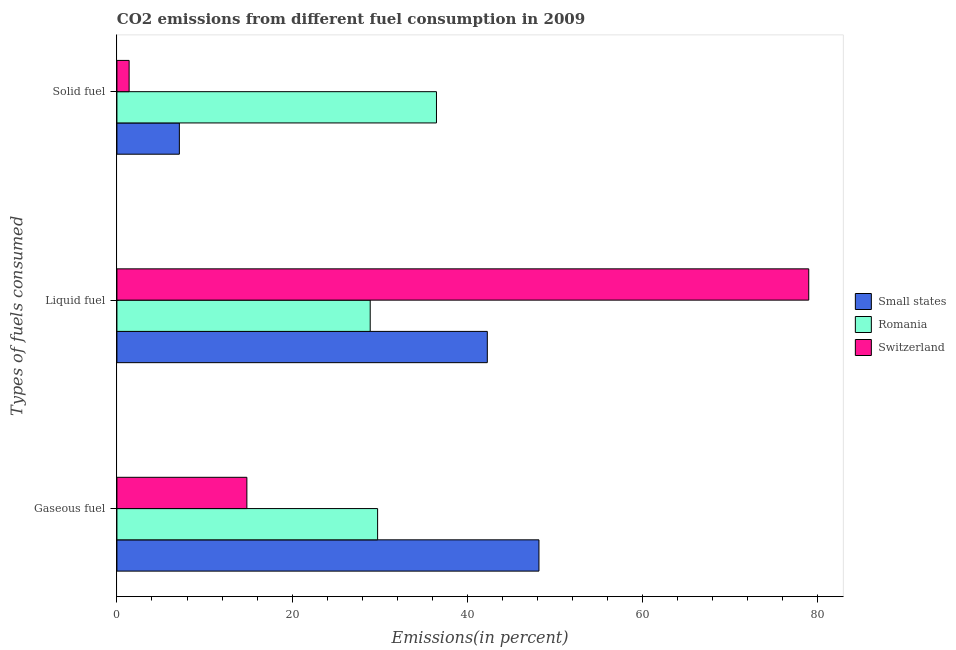How many different coloured bars are there?
Keep it short and to the point. 3. Are the number of bars per tick equal to the number of legend labels?
Ensure brevity in your answer.  Yes. How many bars are there on the 3rd tick from the top?
Your response must be concise. 3. How many bars are there on the 2nd tick from the bottom?
Keep it short and to the point. 3. What is the label of the 3rd group of bars from the top?
Your response must be concise. Gaseous fuel. What is the percentage of liquid fuel emission in Switzerland?
Keep it short and to the point. 78.98. Across all countries, what is the maximum percentage of solid fuel emission?
Keep it short and to the point. 36.48. Across all countries, what is the minimum percentage of liquid fuel emission?
Make the answer very short. 28.91. In which country was the percentage of gaseous fuel emission maximum?
Make the answer very short. Small states. In which country was the percentage of solid fuel emission minimum?
Offer a terse response. Switzerland. What is the total percentage of gaseous fuel emission in the graph?
Offer a terse response. 92.77. What is the difference between the percentage of gaseous fuel emission in Small states and that in Romania?
Offer a very short reply. 18.42. What is the difference between the percentage of liquid fuel emission in Switzerland and the percentage of solid fuel emission in Romania?
Your response must be concise. 42.5. What is the average percentage of gaseous fuel emission per country?
Make the answer very short. 30.92. What is the difference between the percentage of solid fuel emission and percentage of gaseous fuel emission in Romania?
Make the answer very short. 6.72. What is the ratio of the percentage of gaseous fuel emission in Romania to that in Switzerland?
Keep it short and to the point. 2.01. Is the percentage of gaseous fuel emission in Small states less than that in Switzerland?
Ensure brevity in your answer.  No. Is the difference between the percentage of solid fuel emission in Switzerland and Small states greater than the difference between the percentage of gaseous fuel emission in Switzerland and Small states?
Your response must be concise. Yes. What is the difference between the highest and the second highest percentage of solid fuel emission?
Make the answer very short. 29.35. What is the difference between the highest and the lowest percentage of solid fuel emission?
Keep it short and to the point. 35.09. Is the sum of the percentage of liquid fuel emission in Small states and Romania greater than the maximum percentage of gaseous fuel emission across all countries?
Provide a succinct answer. Yes. What does the 2nd bar from the top in Solid fuel represents?
Your response must be concise. Romania. What does the 1st bar from the bottom in Solid fuel represents?
Your answer should be compact. Small states. Is it the case that in every country, the sum of the percentage of gaseous fuel emission and percentage of liquid fuel emission is greater than the percentage of solid fuel emission?
Provide a succinct answer. Yes. How many bars are there?
Keep it short and to the point. 9. Are all the bars in the graph horizontal?
Offer a terse response. Yes. How many countries are there in the graph?
Offer a very short reply. 3. What is the difference between two consecutive major ticks on the X-axis?
Keep it short and to the point. 20. Does the graph contain any zero values?
Ensure brevity in your answer.  No. Where does the legend appear in the graph?
Your response must be concise. Center right. What is the title of the graph?
Keep it short and to the point. CO2 emissions from different fuel consumption in 2009. What is the label or title of the X-axis?
Ensure brevity in your answer.  Emissions(in percent). What is the label or title of the Y-axis?
Offer a very short reply. Types of fuels consumed. What is the Emissions(in percent) in Small states in Gaseous fuel?
Your response must be concise. 48.18. What is the Emissions(in percent) in Romania in Gaseous fuel?
Offer a very short reply. 29.76. What is the Emissions(in percent) of Switzerland in Gaseous fuel?
Provide a succinct answer. 14.83. What is the Emissions(in percent) in Small states in Liquid fuel?
Make the answer very short. 42.28. What is the Emissions(in percent) in Romania in Liquid fuel?
Keep it short and to the point. 28.91. What is the Emissions(in percent) in Switzerland in Liquid fuel?
Your answer should be very brief. 78.98. What is the Emissions(in percent) of Small states in Solid fuel?
Provide a short and direct response. 7.13. What is the Emissions(in percent) of Romania in Solid fuel?
Provide a short and direct response. 36.48. What is the Emissions(in percent) of Switzerland in Solid fuel?
Offer a very short reply. 1.39. Across all Types of fuels consumed, what is the maximum Emissions(in percent) of Small states?
Ensure brevity in your answer.  48.18. Across all Types of fuels consumed, what is the maximum Emissions(in percent) of Romania?
Your answer should be compact. 36.48. Across all Types of fuels consumed, what is the maximum Emissions(in percent) in Switzerland?
Offer a very short reply. 78.98. Across all Types of fuels consumed, what is the minimum Emissions(in percent) of Small states?
Your answer should be compact. 7.13. Across all Types of fuels consumed, what is the minimum Emissions(in percent) in Romania?
Provide a succinct answer. 28.91. Across all Types of fuels consumed, what is the minimum Emissions(in percent) of Switzerland?
Your response must be concise. 1.39. What is the total Emissions(in percent) in Small states in the graph?
Provide a succinct answer. 97.59. What is the total Emissions(in percent) in Romania in the graph?
Make the answer very short. 95.15. What is the total Emissions(in percent) of Switzerland in the graph?
Provide a short and direct response. 95.2. What is the difference between the Emissions(in percent) in Small states in Gaseous fuel and that in Liquid fuel?
Your answer should be compact. 5.9. What is the difference between the Emissions(in percent) in Romania in Gaseous fuel and that in Liquid fuel?
Offer a terse response. 0.85. What is the difference between the Emissions(in percent) of Switzerland in Gaseous fuel and that in Liquid fuel?
Your response must be concise. -64.14. What is the difference between the Emissions(in percent) of Small states in Gaseous fuel and that in Solid fuel?
Make the answer very short. 41.05. What is the difference between the Emissions(in percent) in Romania in Gaseous fuel and that in Solid fuel?
Provide a short and direct response. -6.72. What is the difference between the Emissions(in percent) of Switzerland in Gaseous fuel and that in Solid fuel?
Provide a short and direct response. 13.44. What is the difference between the Emissions(in percent) of Small states in Liquid fuel and that in Solid fuel?
Your response must be concise. 35.16. What is the difference between the Emissions(in percent) of Romania in Liquid fuel and that in Solid fuel?
Offer a very short reply. -7.57. What is the difference between the Emissions(in percent) in Switzerland in Liquid fuel and that in Solid fuel?
Your response must be concise. 77.58. What is the difference between the Emissions(in percent) of Small states in Gaseous fuel and the Emissions(in percent) of Romania in Liquid fuel?
Your answer should be compact. 19.27. What is the difference between the Emissions(in percent) of Small states in Gaseous fuel and the Emissions(in percent) of Switzerland in Liquid fuel?
Your response must be concise. -30.8. What is the difference between the Emissions(in percent) in Romania in Gaseous fuel and the Emissions(in percent) in Switzerland in Liquid fuel?
Offer a terse response. -49.22. What is the difference between the Emissions(in percent) of Small states in Gaseous fuel and the Emissions(in percent) of Romania in Solid fuel?
Keep it short and to the point. 11.7. What is the difference between the Emissions(in percent) in Small states in Gaseous fuel and the Emissions(in percent) in Switzerland in Solid fuel?
Make the answer very short. 46.79. What is the difference between the Emissions(in percent) in Romania in Gaseous fuel and the Emissions(in percent) in Switzerland in Solid fuel?
Ensure brevity in your answer.  28.37. What is the difference between the Emissions(in percent) in Small states in Liquid fuel and the Emissions(in percent) in Romania in Solid fuel?
Give a very brief answer. 5.8. What is the difference between the Emissions(in percent) of Small states in Liquid fuel and the Emissions(in percent) of Switzerland in Solid fuel?
Give a very brief answer. 40.89. What is the difference between the Emissions(in percent) of Romania in Liquid fuel and the Emissions(in percent) of Switzerland in Solid fuel?
Your answer should be compact. 27.52. What is the average Emissions(in percent) in Small states per Types of fuels consumed?
Provide a short and direct response. 32.53. What is the average Emissions(in percent) of Romania per Types of fuels consumed?
Offer a very short reply. 31.72. What is the average Emissions(in percent) of Switzerland per Types of fuels consumed?
Offer a very short reply. 31.73. What is the difference between the Emissions(in percent) in Small states and Emissions(in percent) in Romania in Gaseous fuel?
Provide a succinct answer. 18.42. What is the difference between the Emissions(in percent) of Small states and Emissions(in percent) of Switzerland in Gaseous fuel?
Offer a terse response. 33.34. What is the difference between the Emissions(in percent) in Romania and Emissions(in percent) in Switzerland in Gaseous fuel?
Keep it short and to the point. 14.93. What is the difference between the Emissions(in percent) of Small states and Emissions(in percent) of Romania in Liquid fuel?
Make the answer very short. 13.37. What is the difference between the Emissions(in percent) in Small states and Emissions(in percent) in Switzerland in Liquid fuel?
Make the answer very short. -36.69. What is the difference between the Emissions(in percent) of Romania and Emissions(in percent) of Switzerland in Liquid fuel?
Offer a very short reply. -50.06. What is the difference between the Emissions(in percent) in Small states and Emissions(in percent) in Romania in Solid fuel?
Your answer should be very brief. -29.35. What is the difference between the Emissions(in percent) in Small states and Emissions(in percent) in Switzerland in Solid fuel?
Provide a succinct answer. 5.74. What is the difference between the Emissions(in percent) in Romania and Emissions(in percent) in Switzerland in Solid fuel?
Ensure brevity in your answer.  35.09. What is the ratio of the Emissions(in percent) in Small states in Gaseous fuel to that in Liquid fuel?
Keep it short and to the point. 1.14. What is the ratio of the Emissions(in percent) in Romania in Gaseous fuel to that in Liquid fuel?
Your response must be concise. 1.03. What is the ratio of the Emissions(in percent) in Switzerland in Gaseous fuel to that in Liquid fuel?
Provide a succinct answer. 0.19. What is the ratio of the Emissions(in percent) of Small states in Gaseous fuel to that in Solid fuel?
Offer a terse response. 6.76. What is the ratio of the Emissions(in percent) of Romania in Gaseous fuel to that in Solid fuel?
Provide a succinct answer. 0.82. What is the ratio of the Emissions(in percent) in Switzerland in Gaseous fuel to that in Solid fuel?
Keep it short and to the point. 10.65. What is the ratio of the Emissions(in percent) of Small states in Liquid fuel to that in Solid fuel?
Make the answer very short. 5.93. What is the ratio of the Emissions(in percent) of Romania in Liquid fuel to that in Solid fuel?
Make the answer very short. 0.79. What is the ratio of the Emissions(in percent) of Switzerland in Liquid fuel to that in Solid fuel?
Offer a very short reply. 56.71. What is the difference between the highest and the second highest Emissions(in percent) of Small states?
Offer a terse response. 5.9. What is the difference between the highest and the second highest Emissions(in percent) of Romania?
Make the answer very short. 6.72. What is the difference between the highest and the second highest Emissions(in percent) of Switzerland?
Ensure brevity in your answer.  64.14. What is the difference between the highest and the lowest Emissions(in percent) in Small states?
Make the answer very short. 41.05. What is the difference between the highest and the lowest Emissions(in percent) in Romania?
Provide a short and direct response. 7.57. What is the difference between the highest and the lowest Emissions(in percent) in Switzerland?
Provide a short and direct response. 77.58. 